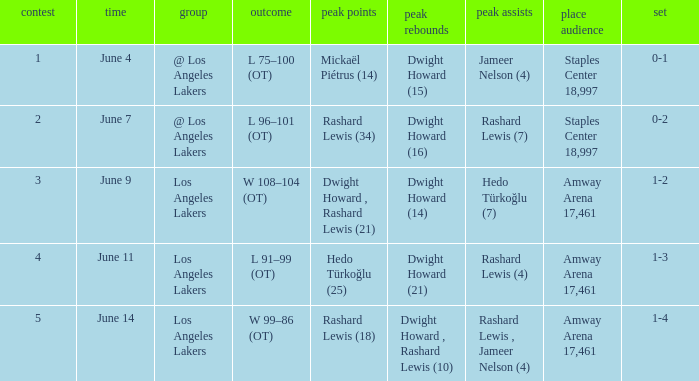What is High Assists, when High Rebounds is "Dwight Howard , Rashard Lewis (10)"? Rashard Lewis , Jameer Nelson (4). 